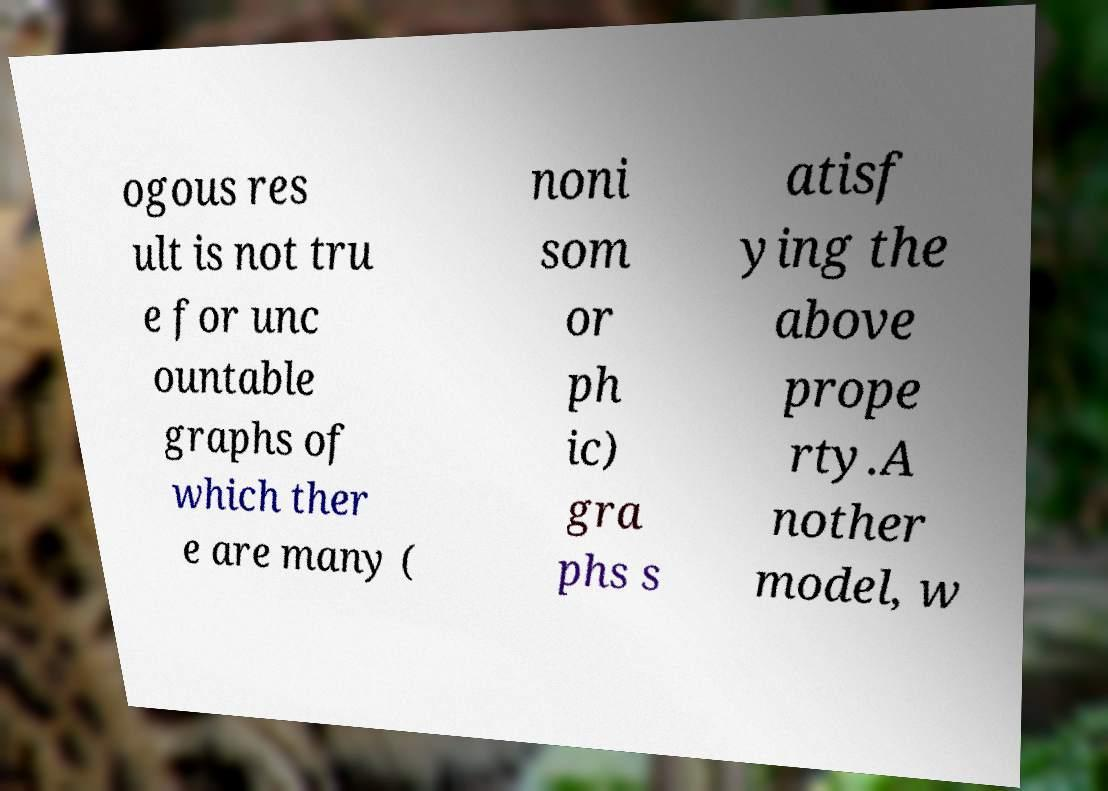Could you assist in decoding the text presented in this image and type it out clearly? ogous res ult is not tru e for unc ountable graphs of which ther e are many ( noni som or ph ic) gra phs s atisf ying the above prope rty.A nother model, w 